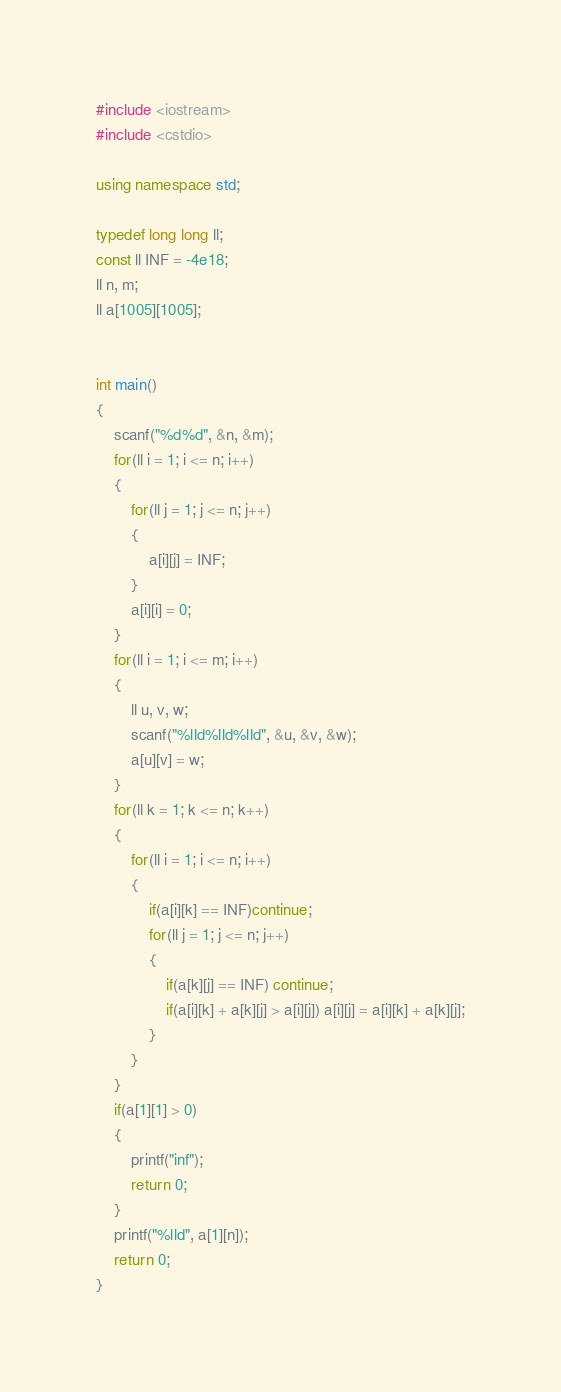<code> <loc_0><loc_0><loc_500><loc_500><_C++_>#include <iostream>
#include <cstdio>

using namespace std;

typedef long long ll;
const ll INF = -4e18;
ll n, m;
ll a[1005][1005];


int main()
{
    scanf("%d%d", &n, &m);
    for(ll i = 1; i <= n; i++)
    {
        for(ll j = 1; j <= n; j++)
        {
            a[i][j] = INF;
        }
        a[i][i] = 0;
    }
    for(ll i = 1; i <= m; i++)
    {
        ll u, v, w;
        scanf("%lld%lld%lld", &u, &v, &w);
        a[u][v] = w;
    }
    for(ll k = 1; k <= n; k++)
    {
        for(ll i = 1; i <= n; i++)
        {
            if(a[i][k] == INF)continue;
            for(ll j = 1; j <= n; j++)
            {
                if(a[k][j] == INF) continue;
                if(a[i][k] + a[k][j] > a[i][j]) a[i][j] = a[i][k] + a[k][j];
            }
        }
    }
    if(a[1][1] > 0)
    {
        printf("inf");
        return 0;
    }
    printf("%lld", a[1][n]);
    return 0;
}
</code> 